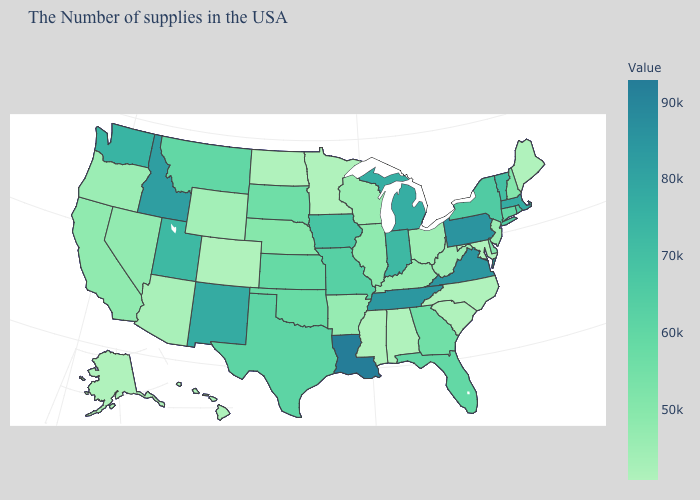Which states have the highest value in the USA?
Give a very brief answer. Louisiana. Does Colorado have the lowest value in the West?
Write a very short answer. Yes. Which states have the lowest value in the USA?
Short answer required. Maine, Maryland, North Carolina, South Carolina, Alabama, Mississippi, Minnesota, North Dakota, Colorado, Alaska. Among the states that border South Dakota , does Wyoming have the lowest value?
Write a very short answer. No. Does Kansas have a lower value than Mississippi?
Write a very short answer. No. Is the legend a continuous bar?
Write a very short answer. Yes. Does Virginia have a higher value than Maryland?
Quick response, please. Yes. 